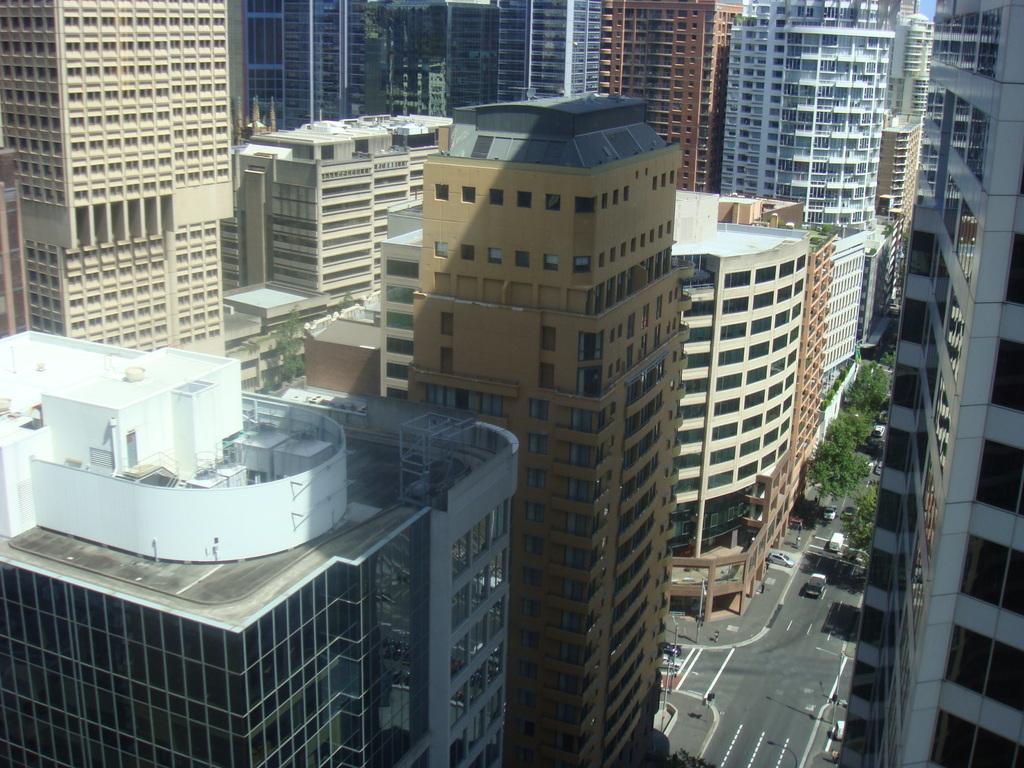In one or two sentences, can you explain what this image depicts? This is the picture of a city. In this image there are buildings. At the top there is sky. At the bottom there are trees and there are vehicles on the road and there are poles on the footpath. 